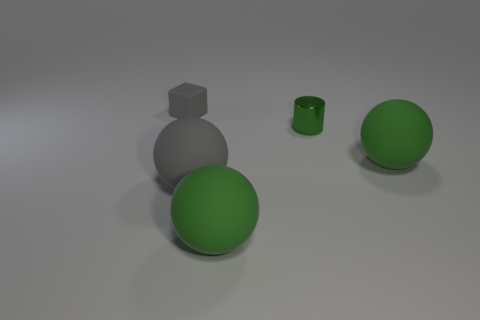Are there any other things that have the same material as the green cylinder?
Offer a very short reply. No. There is a gray thing behind the matte thing right of the tiny green metallic cylinder; what is its shape?
Provide a succinct answer. Cube. Do the metallic thing and the object left of the big gray matte sphere have the same color?
Keep it short and to the point. No. What shape is the large gray object?
Your answer should be very brief. Sphere. There is a gray thing that is to the right of the tiny thing on the left side of the shiny object; how big is it?
Provide a succinct answer. Large. Is the number of gray matte cubes that are to the right of the tiny block the same as the number of gray objects left of the gray rubber sphere?
Make the answer very short. No. What is the material of the object that is both behind the large gray rubber sphere and in front of the green metal cylinder?
Keep it short and to the point. Rubber. Is the size of the cylinder the same as the rubber object that is in front of the big gray object?
Provide a short and direct response. No. How many other things are the same color as the tiny matte object?
Your response must be concise. 1. Are there more large gray rubber things that are left of the tiny cylinder than gray matte balls?
Your answer should be very brief. No. 